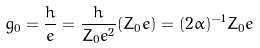Convert formula to latex. <formula><loc_0><loc_0><loc_500><loc_500>g _ { 0 } = \frac { h } { e } = \frac { h } { Z _ { 0 } e ^ { 2 } } ( Z _ { 0 } e ) = ( 2 \alpha ) ^ { - 1 } Z _ { 0 } e</formula> 